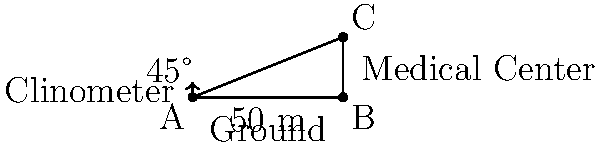Dr. Kim, a Korean-American physician, is advocating for the construction of a new culturally sensitive medical center. To estimate the cost, she needs to determine the height of the proposed building. Using a clinometer, Dr. Kim measures the angle of elevation to the top of the building to be 45°. If she is standing 50 meters away from the base of the building, what is the height of the medical center? Let's approach this step-by-step:

1) In this problem, we have a right triangle where:
   - The adjacent side is the distance from Dr. Kim to the building (50 meters)
   - The opposite side is the height of the building (what we're trying to find)
   - The angle of elevation is 45°

2) We can use the tangent function to solve this. The tangent of an angle in a right triangle is the ratio of the opposite side to the adjacent side.

3) Let's define our variables:
   $h$ = height of the building (opposite side)
   $d$ = distance from Dr. Kim to the building (adjacent side) = 50 m
   $\theta$ = angle of elevation = 45°

4) The tangent function is defined as:
   $\tan \theta = \frac{\text{opposite}}{\text{adjacent}} = \frac{h}{d}$

5) We know that $\tan 45° = 1$. So we can write:
   $1 = \frac{h}{50}$

6) To solve for $h$, we multiply both sides by 50:
   $h = 1 * 50 = 50$

Therefore, the height of the medical center building is 50 meters.
Answer: 50 meters 